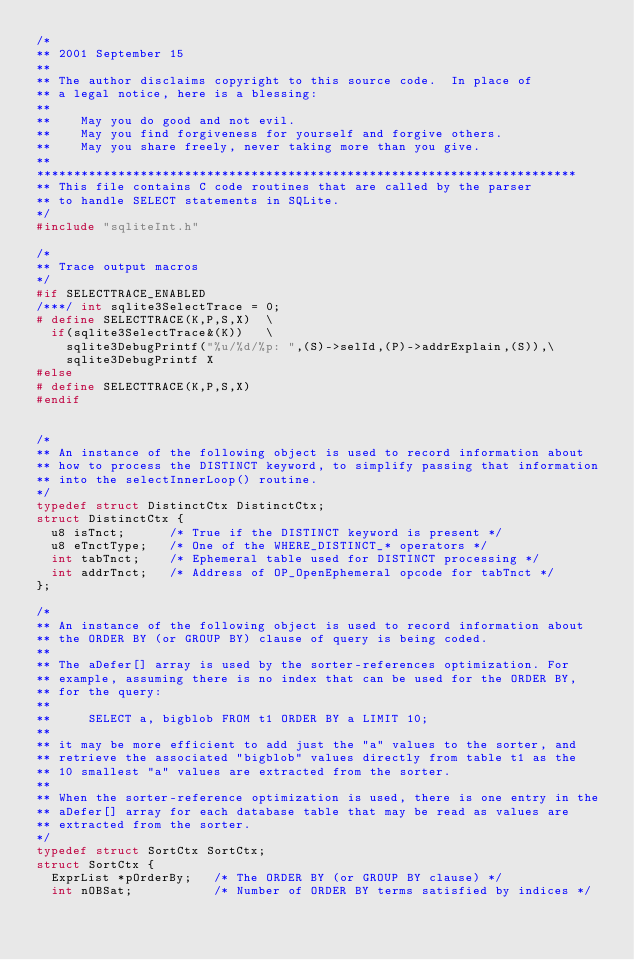<code> <loc_0><loc_0><loc_500><loc_500><_C_>/*
** 2001 September 15
**
** The author disclaims copyright to this source code.  In place of
** a legal notice, here is a blessing:
**
**    May you do good and not evil.
**    May you find forgiveness for yourself and forgive others.
**    May you share freely, never taking more than you give.
**
*************************************************************************
** This file contains C code routines that are called by the parser
** to handle SELECT statements in SQLite.
*/
#include "sqliteInt.h"

/*
** Trace output macros
*/
#if SELECTTRACE_ENABLED
/***/ int sqlite3SelectTrace = 0;
# define SELECTTRACE(K,P,S,X)  \
  if(sqlite3SelectTrace&(K))   \
    sqlite3DebugPrintf("%u/%d/%p: ",(S)->selId,(P)->addrExplain,(S)),\
    sqlite3DebugPrintf X
#else
# define SELECTTRACE(K,P,S,X)
#endif


/*
** An instance of the following object is used to record information about
** how to process the DISTINCT keyword, to simplify passing that information
** into the selectInnerLoop() routine.
*/
typedef struct DistinctCtx DistinctCtx;
struct DistinctCtx {
  u8 isTnct;      /* True if the DISTINCT keyword is present */
  u8 eTnctType;   /* One of the WHERE_DISTINCT_* operators */
  int tabTnct;    /* Ephemeral table used for DISTINCT processing */
  int addrTnct;   /* Address of OP_OpenEphemeral opcode for tabTnct */
};

/*
** An instance of the following object is used to record information about
** the ORDER BY (or GROUP BY) clause of query is being coded.
**
** The aDefer[] array is used by the sorter-references optimization. For
** example, assuming there is no index that can be used for the ORDER BY,
** for the query:
**
**     SELECT a, bigblob FROM t1 ORDER BY a LIMIT 10;
**
** it may be more efficient to add just the "a" values to the sorter, and
** retrieve the associated "bigblob" values directly from table t1 as the
** 10 smallest "a" values are extracted from the sorter.
**
** When the sorter-reference optimization is used, there is one entry in the
** aDefer[] array for each database table that may be read as values are
** extracted from the sorter.
*/
typedef struct SortCtx SortCtx;
struct SortCtx {
  ExprList *pOrderBy;   /* The ORDER BY (or GROUP BY clause) */
  int nOBSat;           /* Number of ORDER BY terms satisfied by indices */</code> 